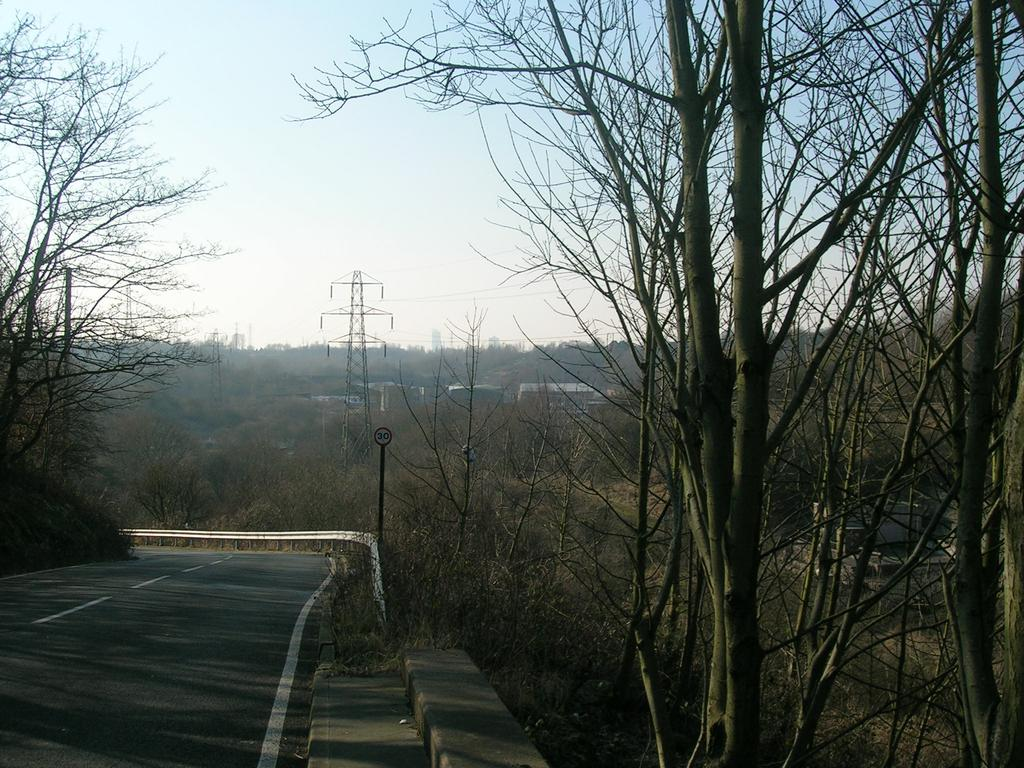What type of vegetation can be seen in the image? There are trees in the image. What structure is present in the image? There is a transmission tower in the image. What else can be seen in the image besides trees and the transmission tower? Electric wires, a road, a barrier, and the sky are visible in the image. What type of dinner is being served in the image? There is no dinner present in the image; it features trees, a transmission tower, electric wires, a road, a barrier, and the sky. What knowledge can be gained from the pigs in the image? There are no pigs present in the image, so no knowledge can be gained from them. 